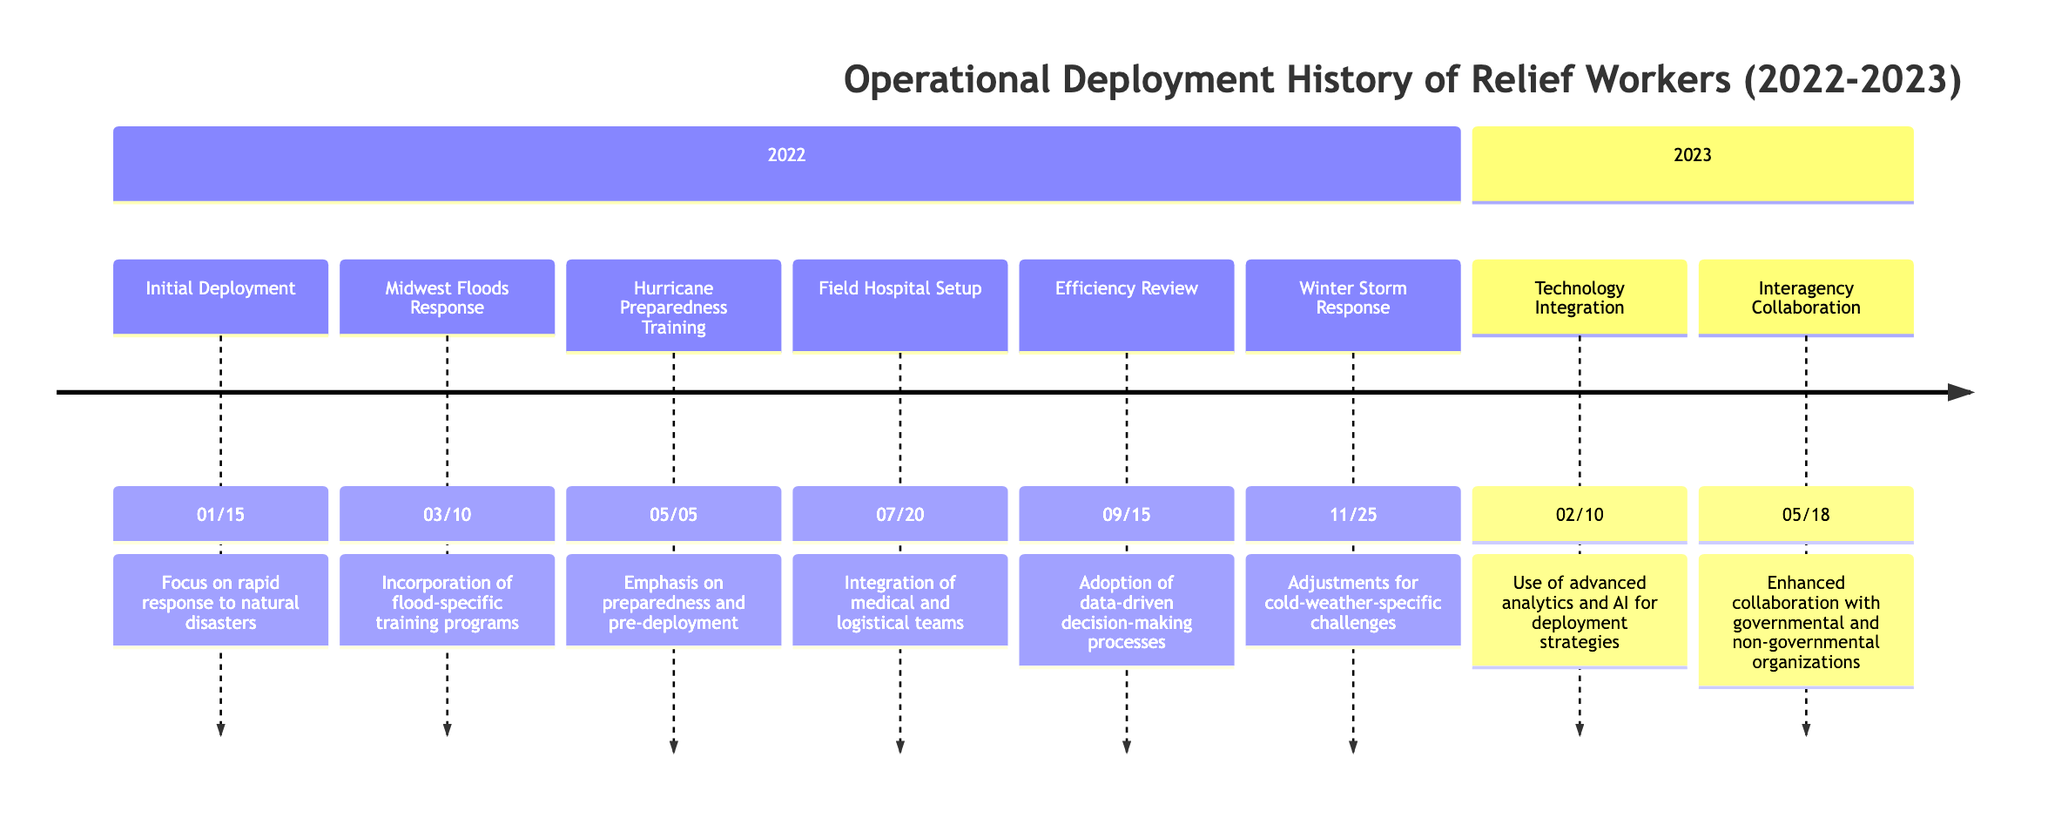What was the date of the Initial Deployment? The Initial Deployment event is listed first on the timeline. According to the data, it occurred on January 15, 2022.
Answer: January 15, 2022 How many major events are documented in 2022? By counting the events listed in the 2022 section of the timeline, there are a total of six events.
Answer: 6 What strategy was emphasized during the Hurricane Preparedness Training? The details for the Hurricane Preparedness Training state that the strategy was "Emphasis on preparedness and pre-deployment." This is directly noted in the event's details.
Answer: Emphasis on preparedness and pre-deployment What significant strategy shift occurred after the Efficiency Review on September 15, 2022? The Efficiency Review led to the shift of adopting data-driven decision-making processes. This strategy shift is directly associated with the event in the timeline.
Answer: Adoption of data-driven decision-making processes Which event reflects the integration of advanced technology for deployment? The Technology Integration event on February 10, 2023, specifies the implementation of new software tools for real-time tracking and optimization, reflecting the idea of advanced technology use.
Answer: Technology Integration What event marked the change in collaboration between organizations? The event titled "Interagency Collaboration" on May 18, 2023, signifies the initiation of a collaborative effort that involves both governmental and non-governmental organizations.
Answer: Interagency Collaboration Which event directly involved medical relief workers? The Field Hospital Setup event on July 20, 2022, specifically notes the deployment of medical relief workers to establish field hospitals.
Answer: Field Hospital Setup What was a key focus during the Midwest Floods Response? According to the event details, there was a focus on incorporating flood-specific training programs during the Midwest Floods Response.
Answer: Incorporation of flood-specific training programs 